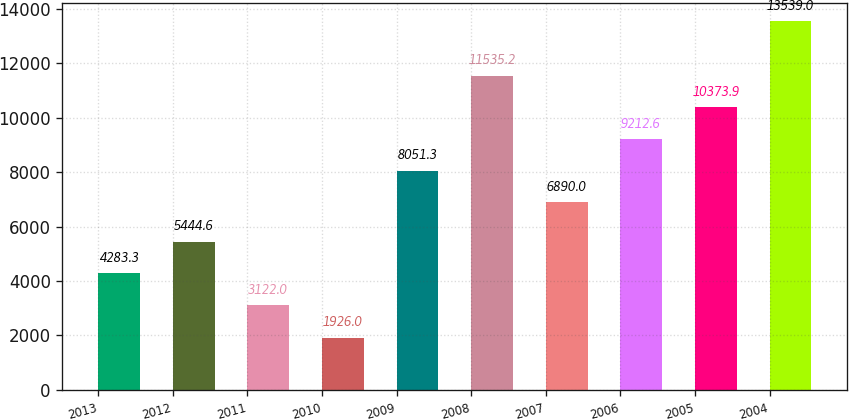Convert chart. <chart><loc_0><loc_0><loc_500><loc_500><bar_chart><fcel>2013<fcel>2012<fcel>2011<fcel>2010<fcel>2009<fcel>2008<fcel>2007<fcel>2006<fcel>2005<fcel>2004<nl><fcel>4283.3<fcel>5444.6<fcel>3122<fcel>1926<fcel>8051.3<fcel>11535.2<fcel>6890<fcel>9212.6<fcel>10373.9<fcel>13539<nl></chart> 